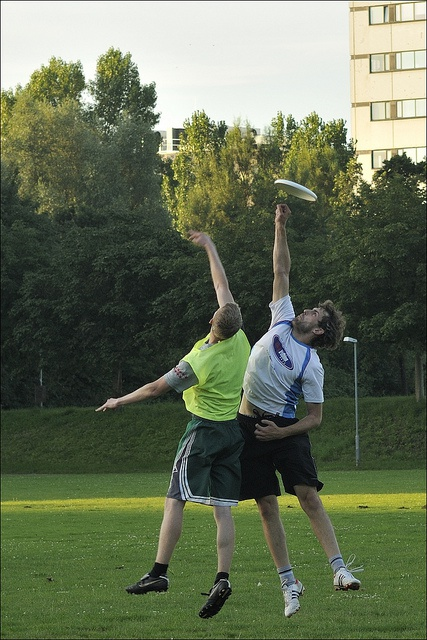Describe the objects in this image and their specific colors. I can see people in black, gray, darkgreen, and darkgray tones, people in black, gray, green, and olive tones, and frisbee in black, gray, darkgreen, darkgray, and lightgray tones in this image. 